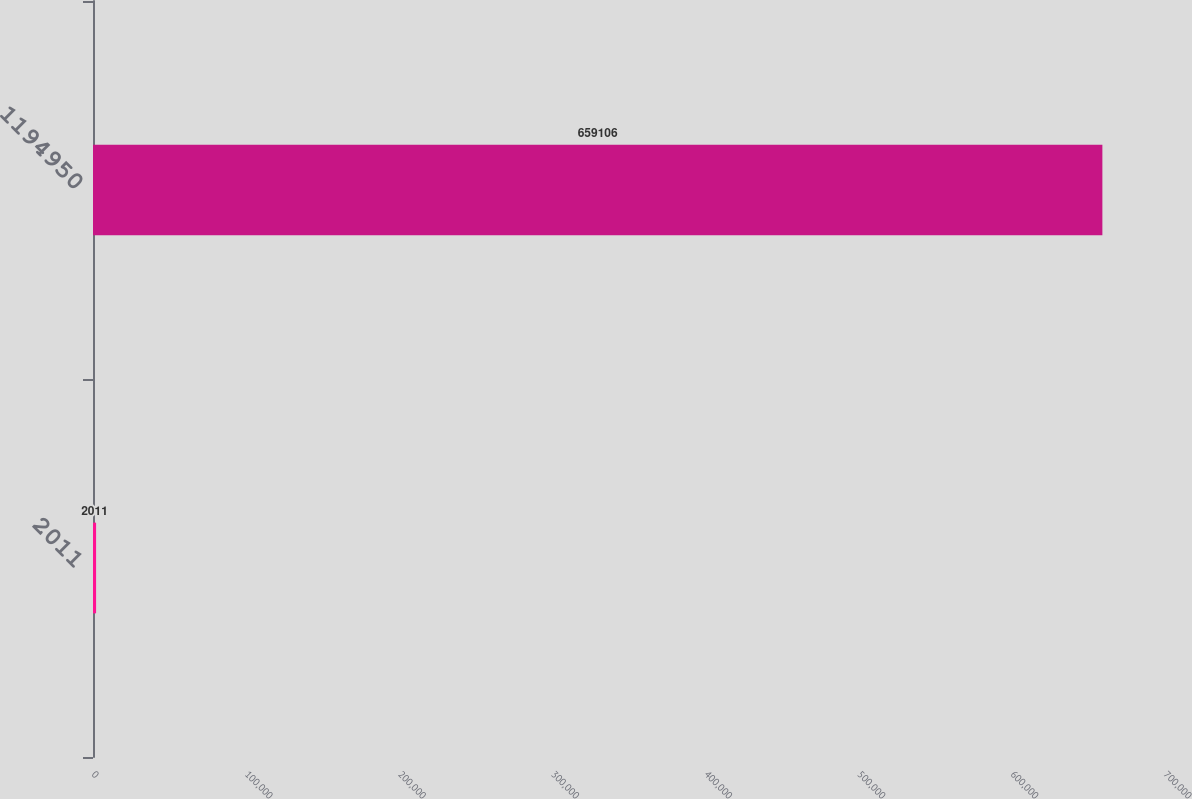Convert chart to OTSL. <chart><loc_0><loc_0><loc_500><loc_500><bar_chart><fcel>2011<fcel>1194950<nl><fcel>2011<fcel>659106<nl></chart> 